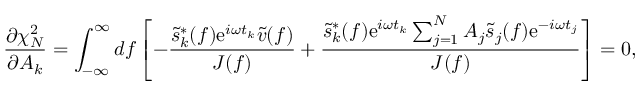Convert formula to latex. <formula><loc_0><loc_0><loc_500><loc_500>\frac { \partial \chi _ { N } ^ { 2 } } { \partial A _ { k } } = \int _ { - \infty } ^ { \infty } d f \left [ - \frac { \tilde { s } _ { k } ^ { * } ( f ) e ^ { i \omega t _ { k } } \tilde { v } ( f ) } { J ( f ) } + \frac { \tilde { s } _ { k } ^ { * } ( f ) e ^ { i \omega t _ { k } } \sum _ { j = 1 } ^ { N } A _ { j } \tilde { s } _ { j } ( f ) e ^ { - i \omega t _ { j } } } { J ( f ) } \right ] = 0 ,</formula> 